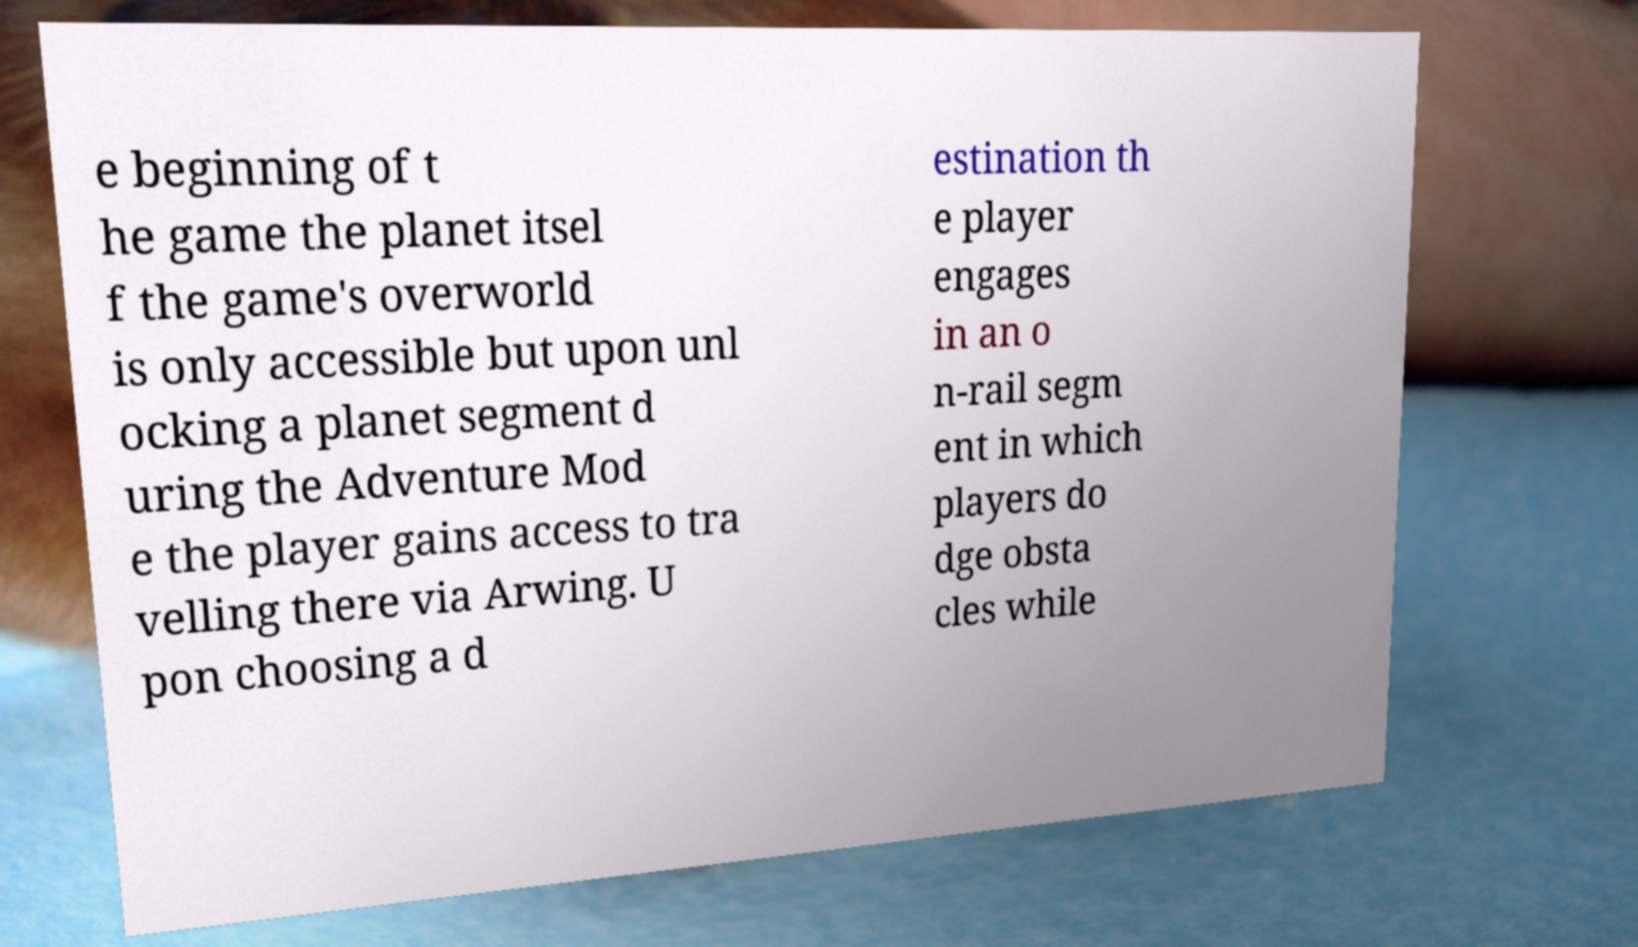What messages or text are displayed in this image? I need them in a readable, typed format. e beginning of t he game the planet itsel f the game's overworld is only accessible but upon unl ocking a planet segment d uring the Adventure Mod e the player gains access to tra velling there via Arwing. U pon choosing a d estination th e player engages in an o n-rail segm ent in which players do dge obsta cles while 